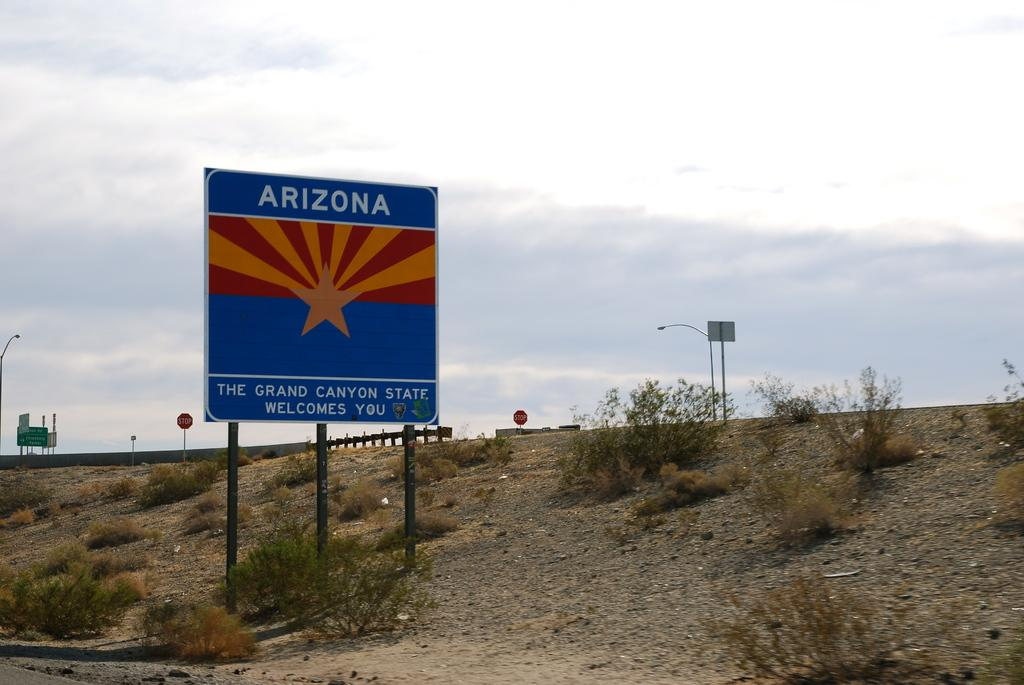<image>
Write a terse but informative summary of the picture. A sign on the side of the road welcoming travellers to Arizona. 